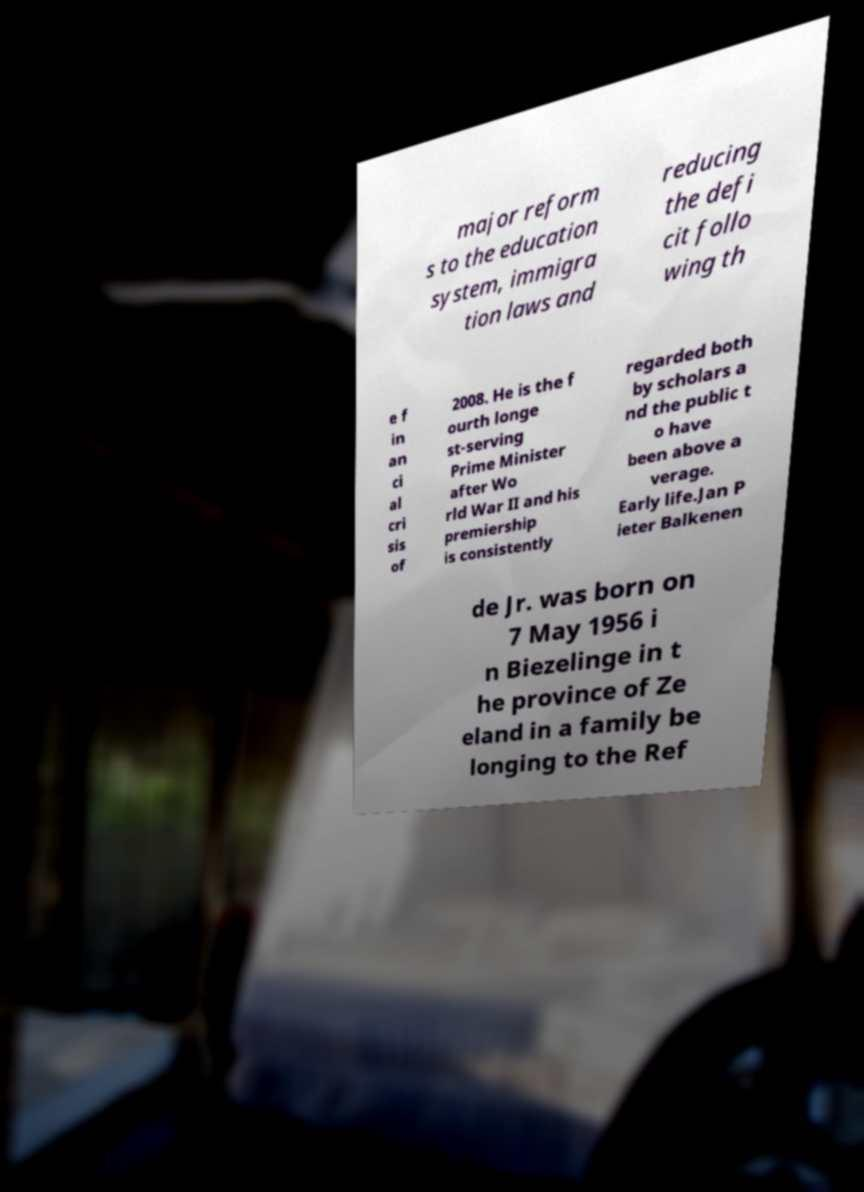There's text embedded in this image that I need extracted. Can you transcribe it verbatim? major reform s to the education system, immigra tion laws and reducing the defi cit follo wing th e f in an ci al cri sis of 2008. He is the f ourth longe st-serving Prime Minister after Wo rld War II and his premiership is consistently regarded both by scholars a nd the public t o have been above a verage. Early life.Jan P ieter Balkenen de Jr. was born on 7 May 1956 i n Biezelinge in t he province of Ze eland in a family be longing to the Ref 